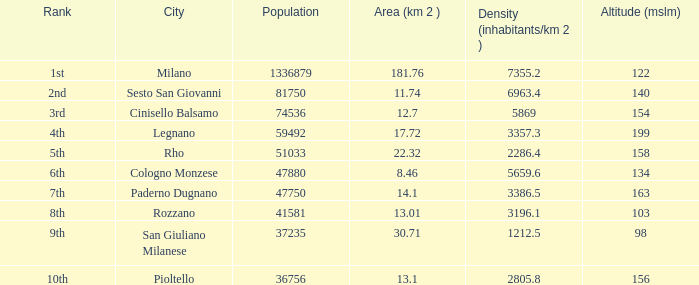Which population has an elevation (mslm) greater than 98, and a density (inhabitants/km 2) exceeding 5869, and a ranking of 1st? 1336879.0. 